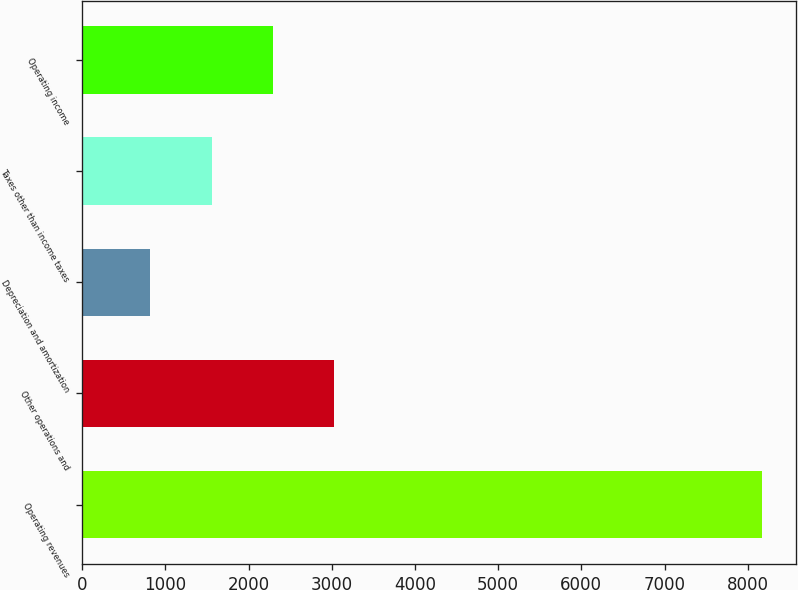Convert chart. <chart><loc_0><loc_0><loc_500><loc_500><bar_chart><fcel>Operating revenues<fcel>Other operations and<fcel>Depreciation and amortization<fcel>Taxes other than income taxes<fcel>Operating income<nl><fcel>8172<fcel>3025.6<fcel>820<fcel>1555.2<fcel>2290.4<nl></chart> 